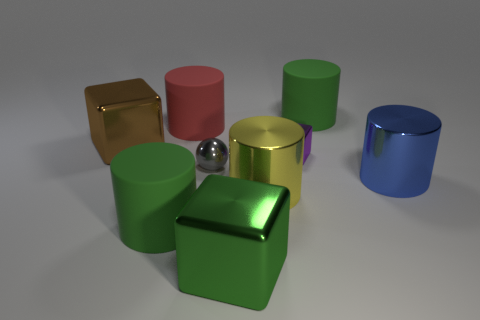How many objects are green rubber things or green objects to the left of the purple shiny block?
Your answer should be very brief. 3. How many other objects are the same shape as the gray shiny object?
Keep it short and to the point. 0. Is the number of green matte objects in front of the big brown object less than the number of green cylinders in front of the yellow thing?
Your response must be concise. No. What shape is the big yellow object that is made of the same material as the small sphere?
Provide a succinct answer. Cylinder. Is there anything else of the same color as the small sphere?
Give a very brief answer. No. What color is the big block that is behind the rubber thing in front of the small gray metallic thing?
Your answer should be very brief. Brown. The large red cylinder that is behind the large metal object to the right of the rubber thing right of the small gray object is made of what material?
Provide a short and direct response. Rubber. How many red cylinders are the same size as the purple thing?
Provide a short and direct response. 0. What is the material of the thing that is both left of the small shiny ball and in front of the big yellow object?
Your answer should be very brief. Rubber. There is a tiny gray metal ball; how many big green matte cylinders are behind it?
Keep it short and to the point. 1. 